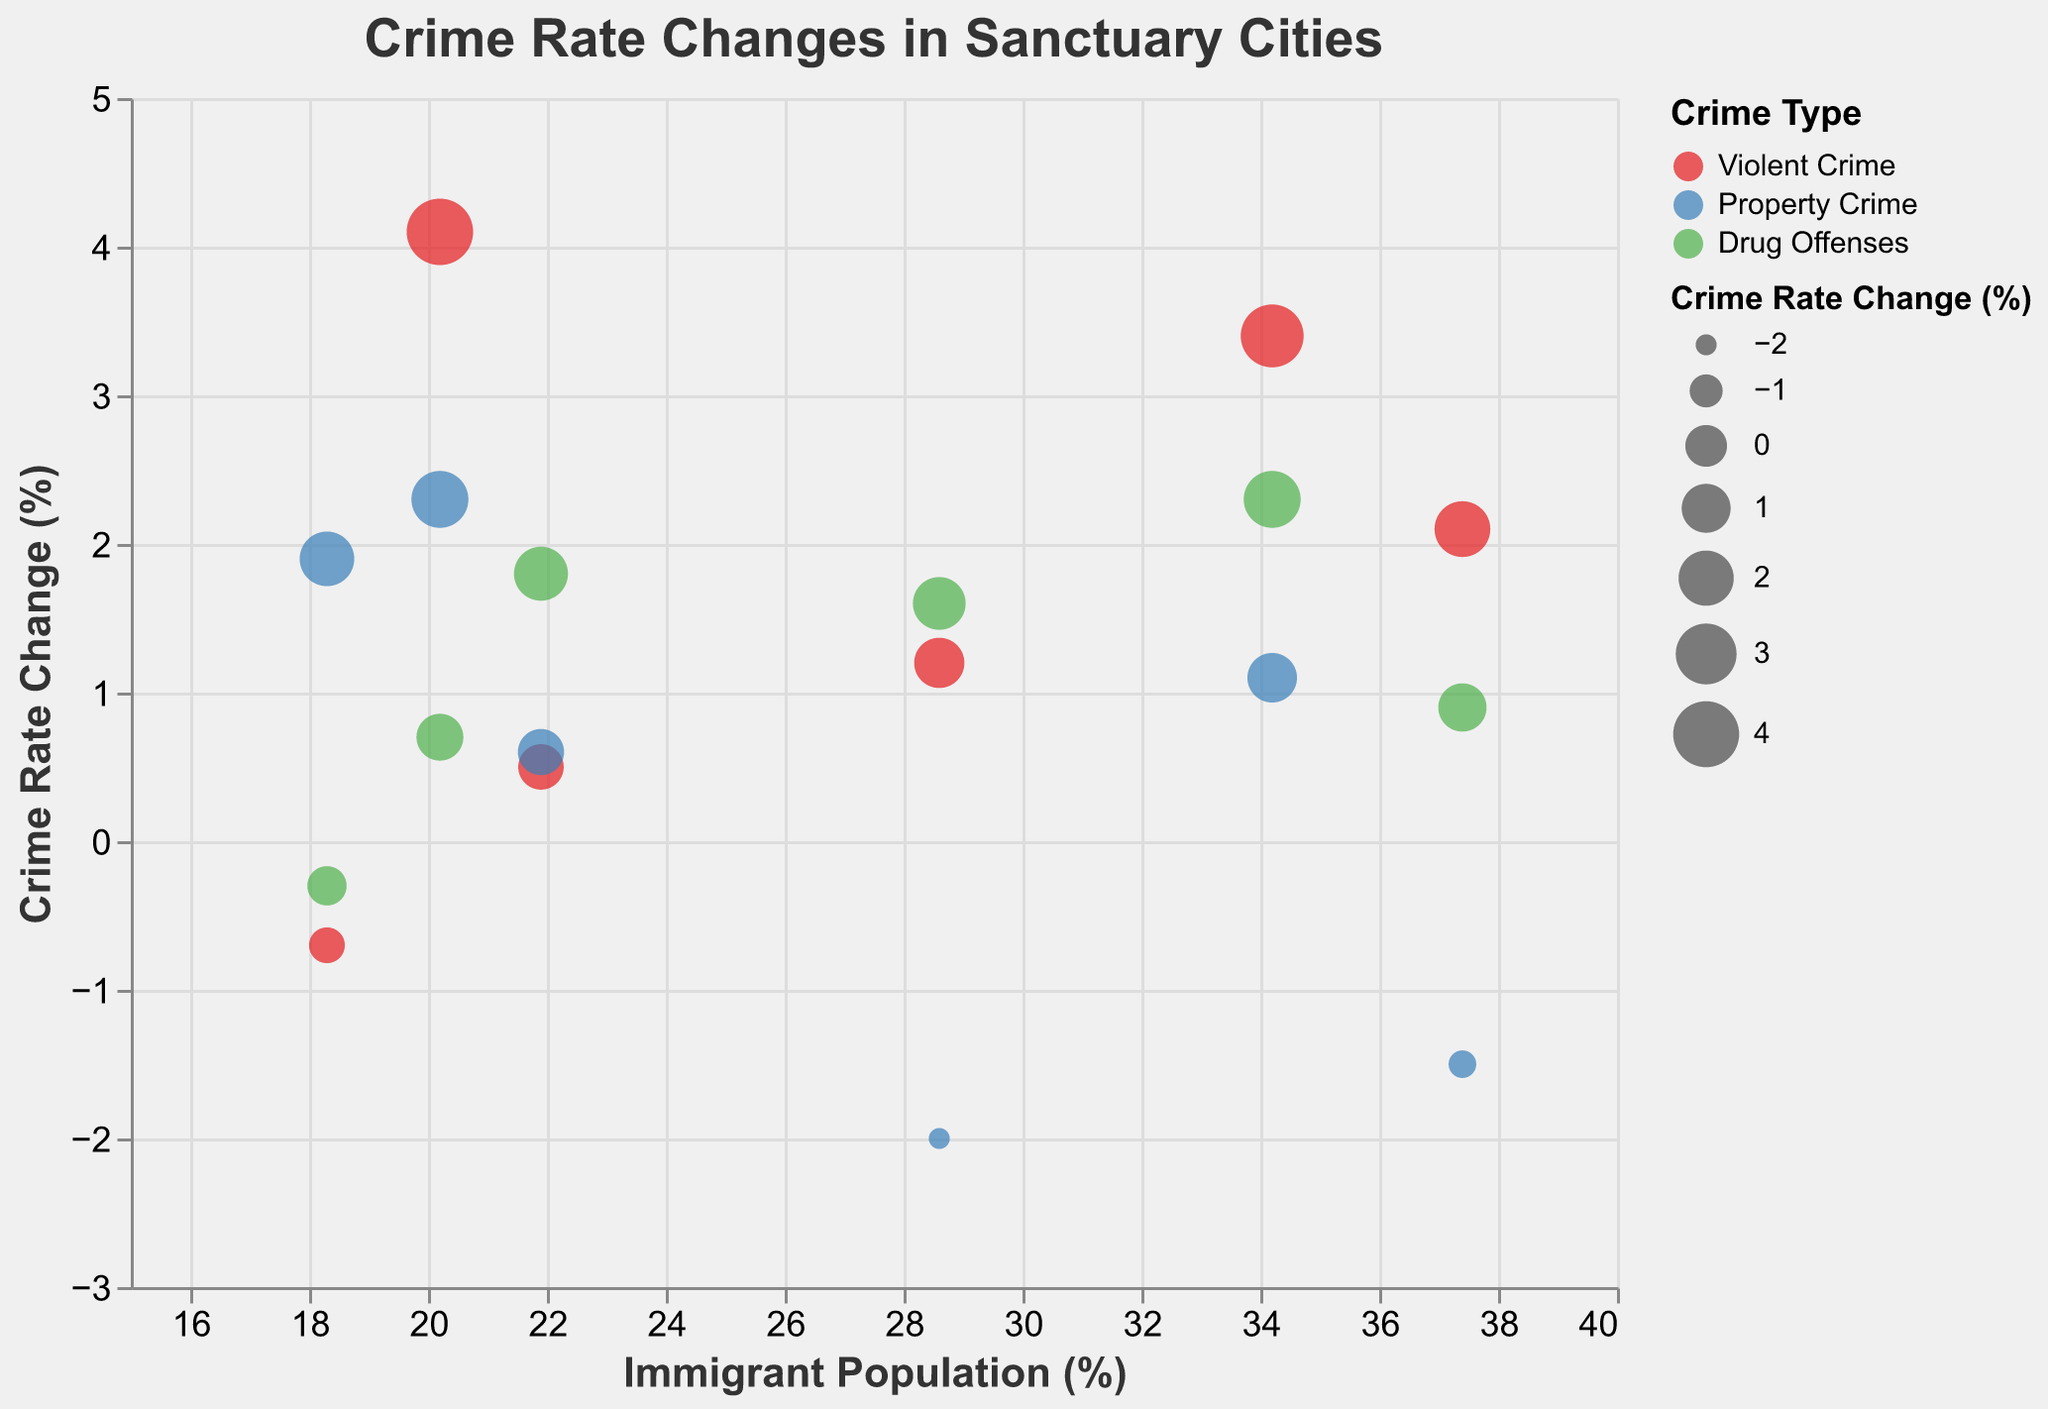What is the title of the figure? The title is located at the top of the figure and is usually the most prominent text. In this case, the title is displayed as "Crime Rate Changes in Sanctuary Cities".
Answer: Crime Rate Changes in Sanctuary Cities Which city has the highest violent crime rate change? Locate the circle that represents the highest value on the y-axis (Crime Rate Change) for "Violent Crime" based on the color legend and tooltip information. Chicago has the highest violent crime rate change of 4.1%.
Answer: Chicago What is the average immigrant population percentage for New York and Los Angeles? First, find the immigrant population percentages for New York (28.6%) and Los Angeles (37.4%). Add these two values (28.6 + 37.4 = 66.0) and then divide by the number of cities (66.0 / 2). The average immigrant population percentage is 33.0%.
Answer: 33.0% Which crime type shows a positive crime rate change in all cities? Check each city's data points for each crime type (Violent Crime, Property Crime, Drug Offenses). Only "Drug Offenses" shows a positive crime rate change in all cities based on their respective data points.
Answer: Drug Offenses How many cities have a higher property crime rate change than their drug offenses rate change? Compare the property crime rate change (%) and the drug offenses rate change (%) for each city. San Francisco (+1.1 vs +2.3) and Chicago (+2.3 vs +0.7) have higher property crime rate changes than drug offenses rate changes.
Answer: 2 Which city has the smallest change in drug offenses crime rate? Identify the data points for "Drug Offenses" and determine the one with the smallest y-axis value. Denver has the smallest change with -0.3%.
Answer: Denver Is there any city where property crime rate change is negative? Check the data points for "Property Crime" and note any points below the x-axis. Both Los Angeles (-1.5%) and New York (-2.0%) have negative property crime rate changes.
Answer: Yes Which city has the highest immigrant population percentage? Identify each city's data points on the x-axis (Immigrant Population (%)). Los Angeles has the highest percentage with 37.4%.
Answer: Los Angeles Are there any cities with a negative change in all crime types? Check each city's data points to see if any city has negative values for all three crime types. No city has negative changes in all crime types based on the data provided.
Answer: No What is the crime type with the highest average crime rate change across all cities? Calculate the average crime rate change for each crime type across all cities and compare. Violent Crime: (2.1 + 3.4 - 0.7 + 1.2 + 0.5 + 4.1) / 6 = 1.77; Property Crime: (-1.5 + 1.1 + 1.9 - 2.0 + 0.6 + 2.3) / 6 = 0.4; Drug Offenses: (0.9 + 2.3 - 0.3 + 1.6 + 1.8 + 0.7) / 6 = 1.17. Violent Crime has the highest average at 1.77%.
Answer: Violent Crime 